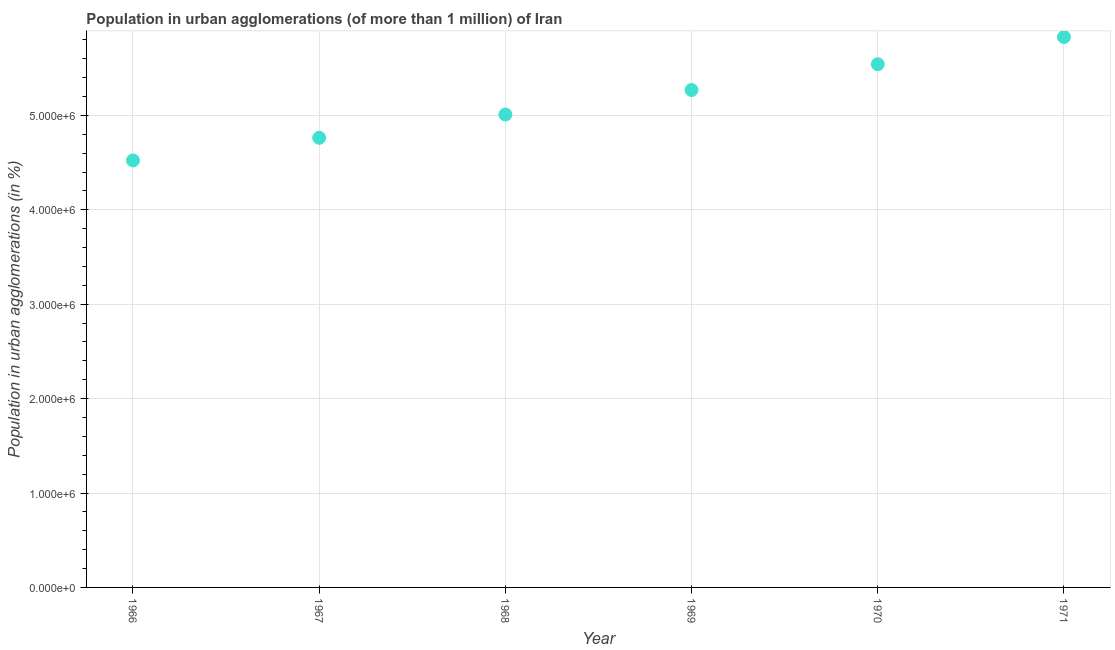What is the population in urban agglomerations in 1966?
Make the answer very short. 4.52e+06. Across all years, what is the maximum population in urban agglomerations?
Make the answer very short. 5.83e+06. Across all years, what is the minimum population in urban agglomerations?
Offer a very short reply. 4.52e+06. In which year was the population in urban agglomerations minimum?
Your response must be concise. 1966. What is the sum of the population in urban agglomerations?
Your answer should be very brief. 3.09e+07. What is the difference between the population in urban agglomerations in 1966 and 1971?
Provide a short and direct response. -1.31e+06. What is the average population in urban agglomerations per year?
Your answer should be very brief. 5.16e+06. What is the median population in urban agglomerations?
Give a very brief answer. 5.14e+06. Do a majority of the years between 1969 and 1966 (inclusive) have population in urban agglomerations greater than 5600000 %?
Provide a short and direct response. Yes. What is the ratio of the population in urban agglomerations in 1967 to that in 1969?
Your answer should be very brief. 0.9. Is the population in urban agglomerations in 1969 less than that in 1971?
Make the answer very short. Yes. What is the difference between the highest and the second highest population in urban agglomerations?
Keep it short and to the point. 2.88e+05. What is the difference between the highest and the lowest population in urban agglomerations?
Give a very brief answer. 1.31e+06. In how many years, is the population in urban agglomerations greater than the average population in urban agglomerations taken over all years?
Provide a short and direct response. 3. Does the graph contain grids?
Offer a terse response. Yes. What is the title of the graph?
Your answer should be compact. Population in urban agglomerations (of more than 1 million) of Iran. What is the label or title of the X-axis?
Make the answer very short. Year. What is the label or title of the Y-axis?
Your response must be concise. Population in urban agglomerations (in %). What is the Population in urban agglomerations (in %) in 1966?
Your answer should be compact. 4.52e+06. What is the Population in urban agglomerations (in %) in 1967?
Your answer should be compact. 4.76e+06. What is the Population in urban agglomerations (in %) in 1968?
Your answer should be very brief. 5.01e+06. What is the Population in urban agglomerations (in %) in 1969?
Offer a very short reply. 5.27e+06. What is the Population in urban agglomerations (in %) in 1970?
Make the answer very short. 5.54e+06. What is the Population in urban agglomerations (in %) in 1971?
Make the answer very short. 5.83e+06. What is the difference between the Population in urban agglomerations (in %) in 1966 and 1967?
Provide a succinct answer. -2.40e+05. What is the difference between the Population in urban agglomerations (in %) in 1966 and 1968?
Give a very brief answer. -4.87e+05. What is the difference between the Population in urban agglomerations (in %) in 1966 and 1969?
Provide a short and direct response. -7.46e+05. What is the difference between the Population in urban agglomerations (in %) in 1966 and 1970?
Provide a short and direct response. -1.02e+06. What is the difference between the Population in urban agglomerations (in %) in 1966 and 1971?
Offer a terse response. -1.31e+06. What is the difference between the Population in urban agglomerations (in %) in 1967 and 1968?
Keep it short and to the point. -2.47e+05. What is the difference between the Population in urban agglomerations (in %) in 1967 and 1969?
Provide a succinct answer. -5.06e+05. What is the difference between the Population in urban agglomerations (in %) in 1967 and 1970?
Offer a very short reply. -7.80e+05. What is the difference between the Population in urban agglomerations (in %) in 1967 and 1971?
Offer a terse response. -1.07e+06. What is the difference between the Population in urban agglomerations (in %) in 1968 and 1969?
Your response must be concise. -2.59e+05. What is the difference between the Population in urban agglomerations (in %) in 1968 and 1970?
Ensure brevity in your answer.  -5.33e+05. What is the difference between the Population in urban agglomerations (in %) in 1968 and 1971?
Provide a short and direct response. -8.21e+05. What is the difference between the Population in urban agglomerations (in %) in 1969 and 1970?
Offer a terse response. -2.74e+05. What is the difference between the Population in urban agglomerations (in %) in 1969 and 1971?
Your answer should be compact. -5.62e+05. What is the difference between the Population in urban agglomerations (in %) in 1970 and 1971?
Ensure brevity in your answer.  -2.88e+05. What is the ratio of the Population in urban agglomerations (in %) in 1966 to that in 1967?
Make the answer very short. 0.95. What is the ratio of the Population in urban agglomerations (in %) in 1966 to that in 1968?
Offer a very short reply. 0.9. What is the ratio of the Population in urban agglomerations (in %) in 1966 to that in 1969?
Provide a succinct answer. 0.86. What is the ratio of the Population in urban agglomerations (in %) in 1966 to that in 1970?
Make the answer very short. 0.82. What is the ratio of the Population in urban agglomerations (in %) in 1966 to that in 1971?
Your response must be concise. 0.78. What is the ratio of the Population in urban agglomerations (in %) in 1967 to that in 1968?
Make the answer very short. 0.95. What is the ratio of the Population in urban agglomerations (in %) in 1967 to that in 1969?
Ensure brevity in your answer.  0.9. What is the ratio of the Population in urban agglomerations (in %) in 1967 to that in 1970?
Your response must be concise. 0.86. What is the ratio of the Population in urban agglomerations (in %) in 1967 to that in 1971?
Offer a terse response. 0.82. What is the ratio of the Population in urban agglomerations (in %) in 1968 to that in 1969?
Make the answer very short. 0.95. What is the ratio of the Population in urban agglomerations (in %) in 1968 to that in 1970?
Ensure brevity in your answer.  0.9. What is the ratio of the Population in urban agglomerations (in %) in 1968 to that in 1971?
Offer a very short reply. 0.86. What is the ratio of the Population in urban agglomerations (in %) in 1969 to that in 1970?
Ensure brevity in your answer.  0.95. What is the ratio of the Population in urban agglomerations (in %) in 1969 to that in 1971?
Provide a short and direct response. 0.9. What is the ratio of the Population in urban agglomerations (in %) in 1970 to that in 1971?
Offer a very short reply. 0.95. 